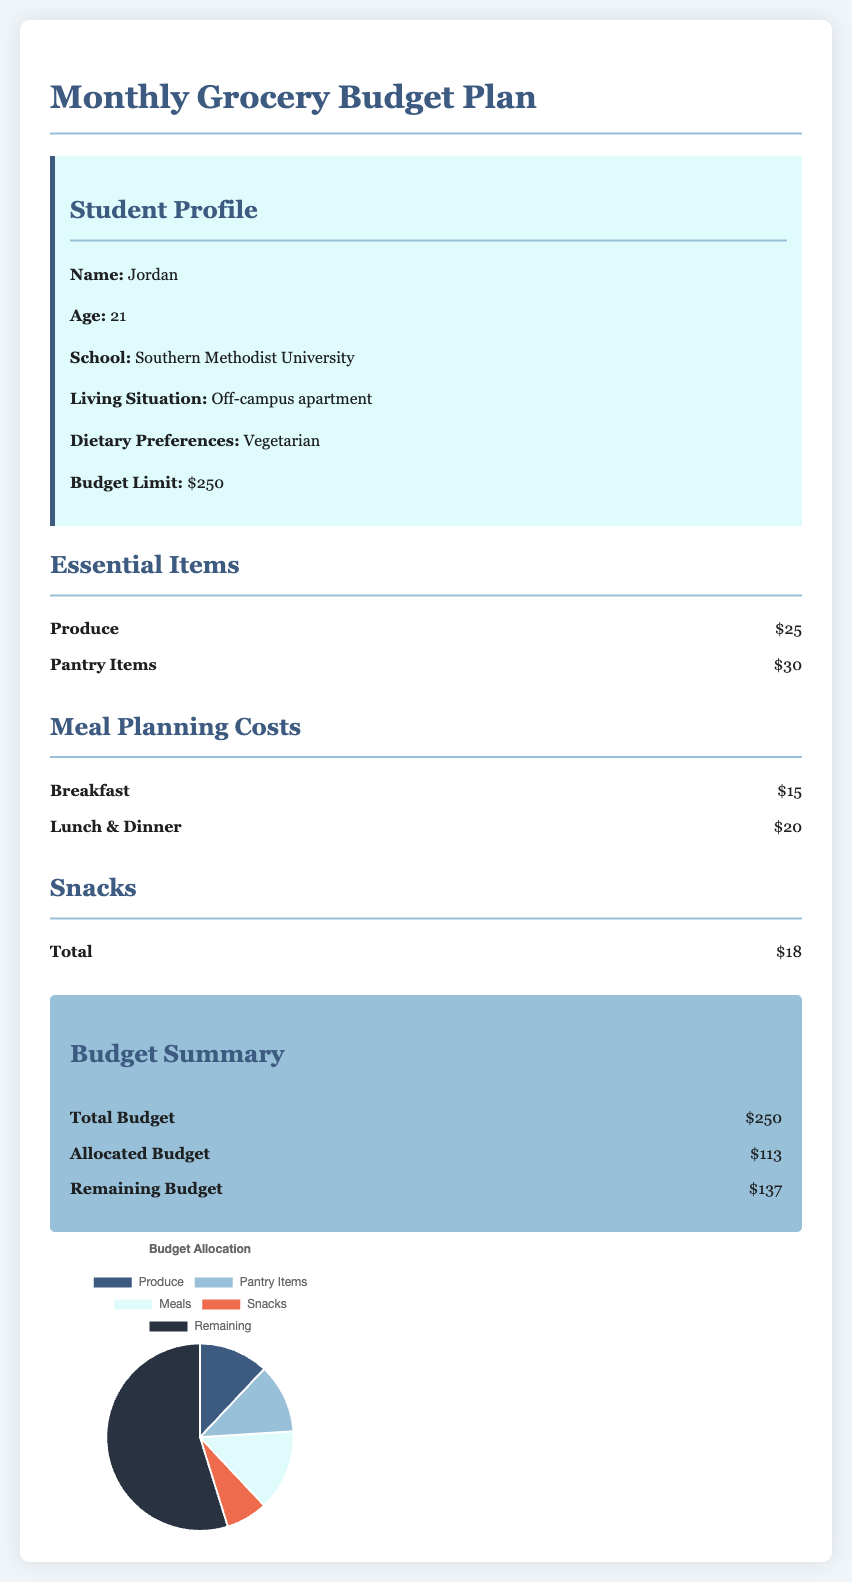what is the student's name? The student's name is provided in the profile section, which is Jordan.
Answer: Jordan what is the total budget limit for the month? The total budget limit is specified in the student profile, which shows $250.
Answer: $250 how much is allocated for produce? The allocated cost for produce is listed in the essential items section, which is $25.
Answer: $25 what is the cost for lunch and dinner? The cost for lunch and dinner is presented in the meal planning costs section, which is $20.
Answer: $20 what is the total remaining budget? The remaining budget is calculated from the budget summary section, which shows $137.
Answer: $137 how much is allocated for snacks? The allocated cost for snacks is listed in the snacks section, which is $18.
Answer: $18 what percentage of the budget is allocated for meals? To find the percentage allocated for meals, we add breakfast ($15) and lunch & dinner ($20) for a total of $35 from the total budget of $250, yielding 14%.
Answer: 14% how many essential items are listed? The document lists two categories under essential items: produce and pantry items.
Answer: 2 what is the color representing pantry items in the budget chart? In the budget chart, pantry items are represented by the color light blue.
Answer: light blue 